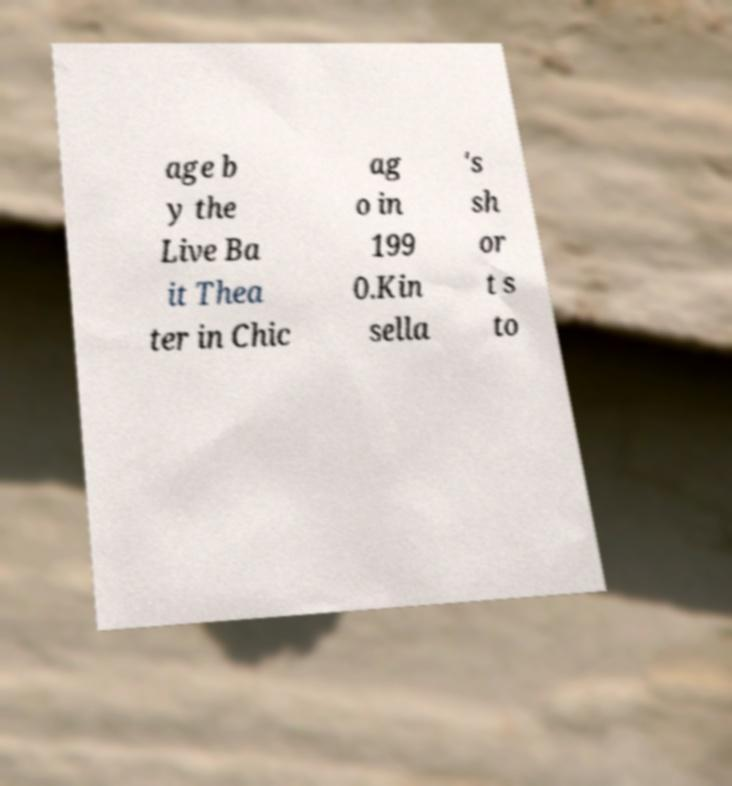Could you extract and type out the text from this image? age b y the Live Ba it Thea ter in Chic ag o in 199 0.Kin sella 's sh or t s to 